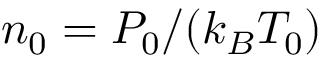<formula> <loc_0><loc_0><loc_500><loc_500>{ { n } _ { 0 } } = { { { P } _ { 0 } } } / { \left ( { { k } _ { B } } { { T } _ { 0 } } \right ) }</formula> 